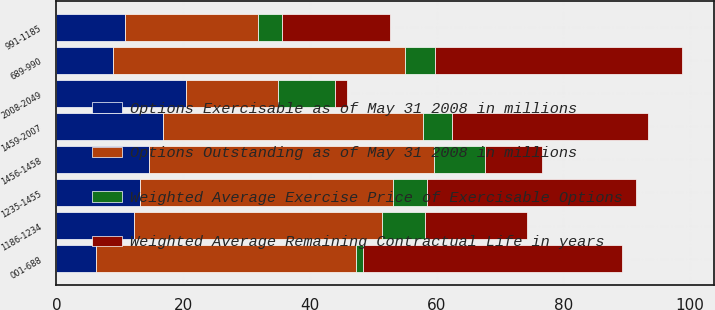Convert chart. <chart><loc_0><loc_0><loc_500><loc_500><stacked_bar_chart><ecel><fcel>001-688<fcel>689-990<fcel>991-1185<fcel>1186-1234<fcel>1235-1455<fcel>1456-1458<fcel>1459-2007<fcel>2008-2049<nl><fcel>Options Outstanding as of May 31 2008 in millions<fcel>41<fcel>46<fcel>21<fcel>39<fcel>40<fcel>45<fcel>41<fcel>14.57<nl><fcel>Weighted Average Exercise Price of Exercisable Options<fcel>1.06<fcel>4.82<fcel>3.85<fcel>6.89<fcel>5.27<fcel>8.08<fcel>4.61<fcel>8.89<nl><fcel>Options Exercisable as of May 31 2008 in millions<fcel>6.29<fcel>8.99<fcel>10.78<fcel>12.32<fcel>13.18<fcel>14.57<fcel>16.85<fcel>20.48<nl><fcel>Weighted Average Remaining Contractual Life in years<fcel>41<fcel>39<fcel>17<fcel>16<fcel>33<fcel>9<fcel>31<fcel>2<nl></chart> 